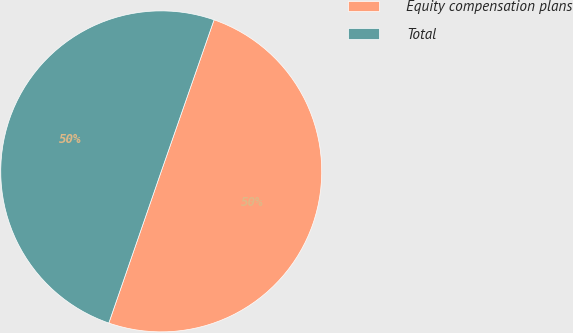Convert chart to OTSL. <chart><loc_0><loc_0><loc_500><loc_500><pie_chart><fcel>Equity compensation plans<fcel>Total<nl><fcel>49.96%<fcel>50.04%<nl></chart> 